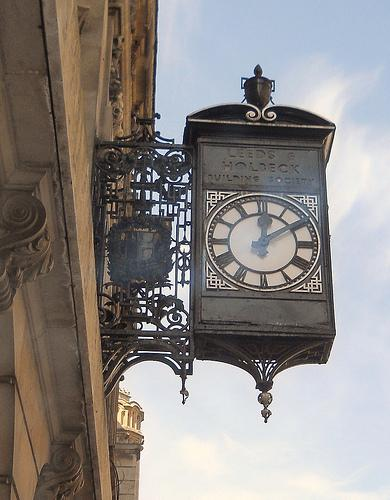What is the condition of the sky in the image? The sky is a beautiful blue with white, wispy clouds, signaling daytime outside. How is the clock attached to the building? The clock is attached to the side of the building with a black metal connector and an iron bracket. What other constructions can be seen near the building with the clock? Near the clock is a tall building with windows and a pointed corner, featuring a design on the concrete surface. Describe the building and clock in the image. The building is tan and dark brown with stone construction, and the clock on its side has a dark brown and white face, Roman numerals, and black hands. Describe the designs and decorations around the clock. There are ornate designs around the clock, including swirls on top and pointed shapes at the bottom, all enclosed in a metal box. Mention the key colors visible in the image. Tan, dark brown, white, black, and a beautiful blue are the main colors present in the image. Give a description of the clock's face and hands. The clock has a white face, Roman numerals in black, and black hands, one long and the other short. What is the most striking feature of the image? The old looking clock with a white face, Roman numerals, and black hands attached to the side of the tan and dark brown building. What types of numerals can be seen on the clock? Roman numerals, such as twelve, six, five, four, eight, nine, and ten, are displayed in black on the clock's white face. Provide a brief overview of the image. An old building with a large clock attached to its side, featuring a white face and Roman numerals, set against a blue sky with white clouds. 